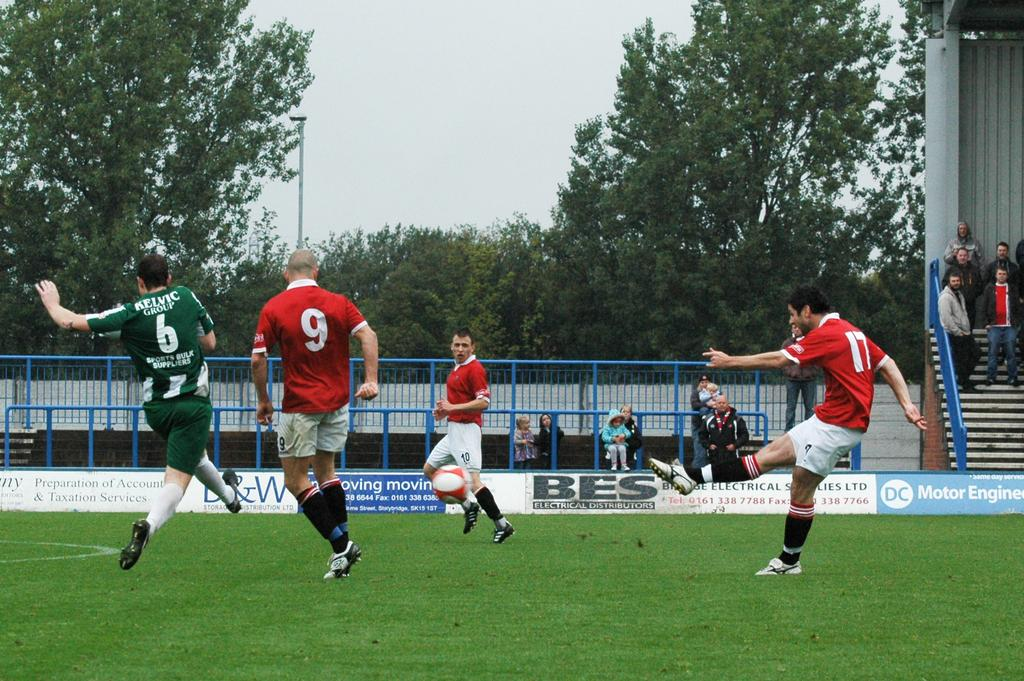Provide a one-sentence caption for the provided image. A soccer player wearing number 17 kicks a ball. 